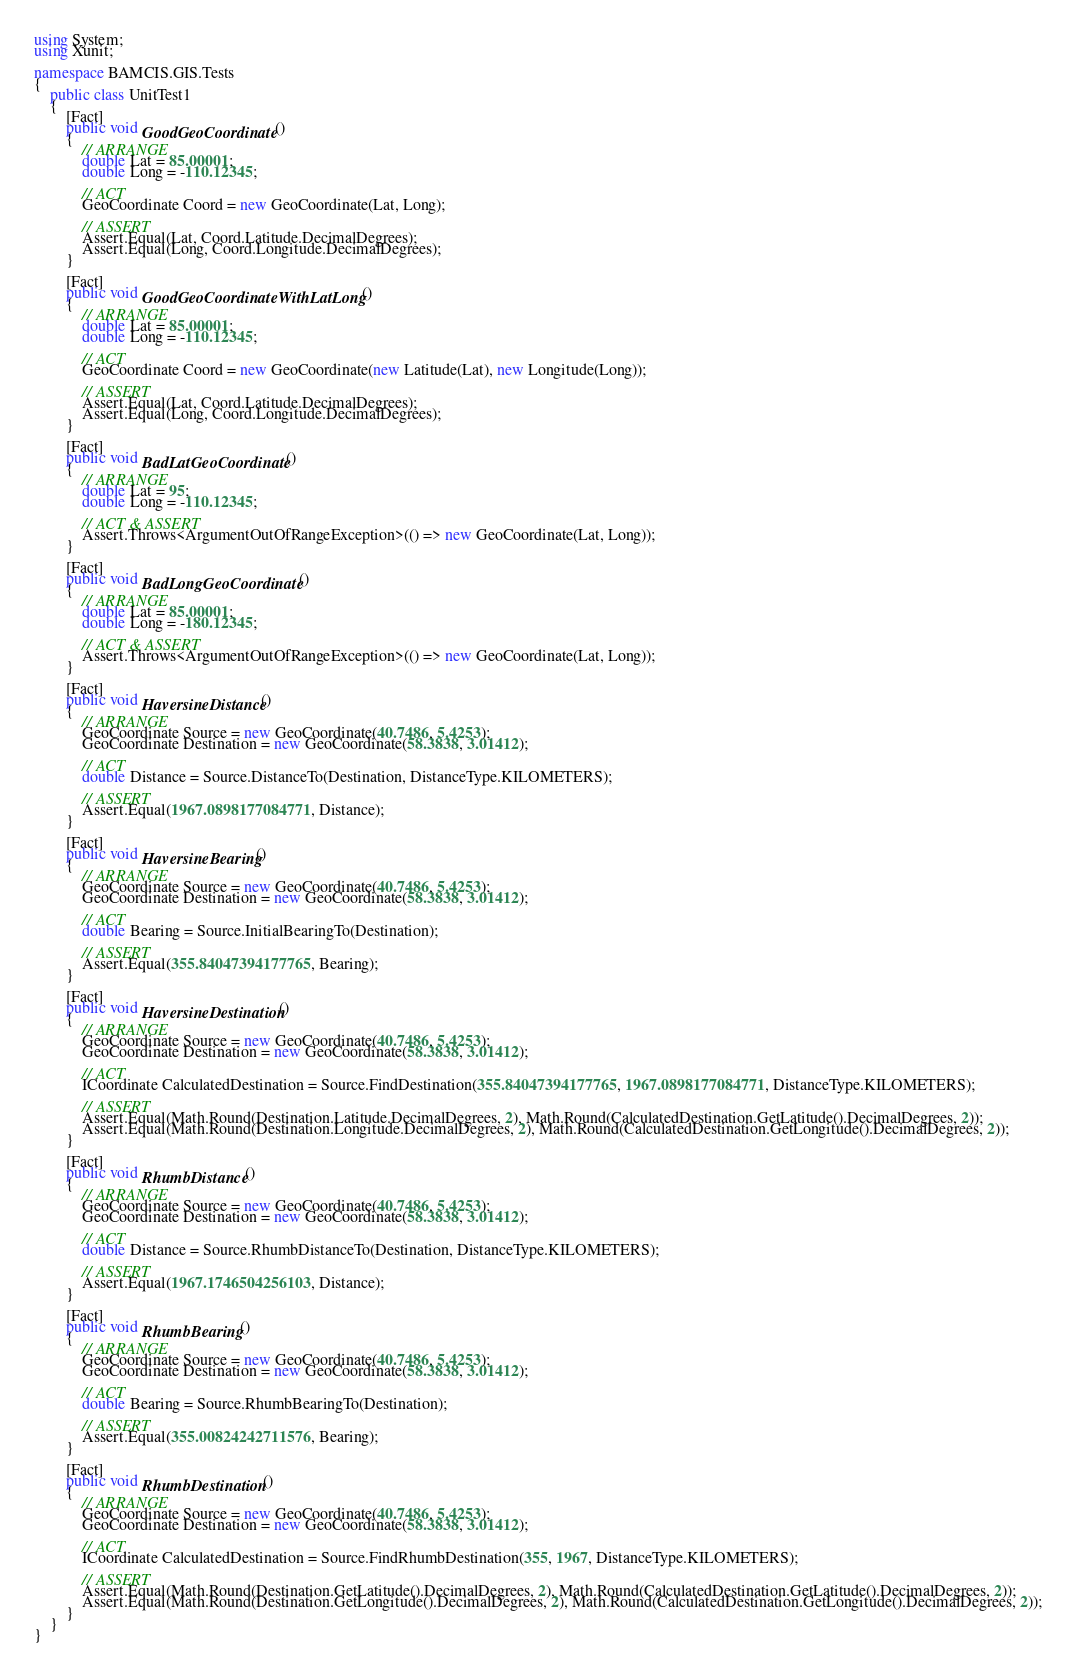<code> <loc_0><loc_0><loc_500><loc_500><_C#_>using System;
using Xunit;

namespace BAMCIS.GIS.Tests
{
    public class UnitTest1
    {
        [Fact]
        public void GoodGeoCoordinate()
        {
            // ARRANGE
            double Lat = 85.00001;
            double Long = -110.12345;

            // ACT
            GeoCoordinate Coord = new GeoCoordinate(Lat, Long);

            // ASSERT
            Assert.Equal(Lat, Coord.Latitude.DecimalDegrees);
            Assert.Equal(Long, Coord.Longitude.DecimalDegrees);
        }

        [Fact]
        public void GoodGeoCoordinateWithLatLong()
        {
            // ARRANGE
            double Lat = 85.00001;
            double Long = -110.12345;

            // ACT
            GeoCoordinate Coord = new GeoCoordinate(new Latitude(Lat), new Longitude(Long));

            // ASSERT
            Assert.Equal(Lat, Coord.Latitude.DecimalDegrees);
            Assert.Equal(Long, Coord.Longitude.DecimalDegrees);
        }

        [Fact]
        public void BadLatGeoCoordinate()
        {
            // ARRANGE
            double Lat = 95;
            double Long = -110.12345;

            // ACT & ASSERT
            Assert.Throws<ArgumentOutOfRangeException>(() => new GeoCoordinate(Lat, Long));
        }

        [Fact]
        public void BadLongGeoCoordinate()
        {
            // ARRANGE
            double Lat = 85.00001;
            double Long = -180.12345;

            // ACT & ASSERT
            Assert.Throws<ArgumentOutOfRangeException>(() => new GeoCoordinate(Lat, Long));
        }

        [Fact]
        public void HaversineDistance()
        {
            // ARRANGE
            GeoCoordinate Source = new GeoCoordinate(40.7486, 5.4253);
            GeoCoordinate Destination = new GeoCoordinate(58.3838, 3.01412);

            // ACT
            double Distance = Source.DistanceTo(Destination, DistanceType.KILOMETERS);

            // ASSERT
            Assert.Equal(1967.0898177084771, Distance);
        }

        [Fact]
        public void HaversineBearing()
        {
            // ARRANGE
            GeoCoordinate Source = new GeoCoordinate(40.7486, 5.4253);
            GeoCoordinate Destination = new GeoCoordinate(58.3838, 3.01412);

            // ACT
            double Bearing = Source.InitialBearingTo(Destination);

            // ASSERT
            Assert.Equal(355.84047394177765, Bearing);
        }

        [Fact]
        public void HaversineDestination()
        {
            // ARRANGE
            GeoCoordinate Source = new GeoCoordinate(40.7486, 5.4253);
            GeoCoordinate Destination = new GeoCoordinate(58.3838, 3.01412);

            // ACT
            ICoordinate CalculatedDestination = Source.FindDestination(355.84047394177765, 1967.0898177084771, DistanceType.KILOMETERS);

            // ASSERT
            Assert.Equal(Math.Round(Destination.Latitude.DecimalDegrees, 2), Math.Round(CalculatedDestination.GetLatitude().DecimalDegrees, 2));
            Assert.Equal(Math.Round(Destination.Longitude.DecimalDegrees, 2), Math.Round(CalculatedDestination.GetLongitude().DecimalDegrees, 2));
        }

        [Fact]
        public void RhumbDistance()
        {
            // ARRANGE
            GeoCoordinate Source = new GeoCoordinate(40.7486, 5.4253);
            GeoCoordinate Destination = new GeoCoordinate(58.3838, 3.01412);

            // ACT
            double Distance = Source.RhumbDistanceTo(Destination, DistanceType.KILOMETERS);

            // ASSERT
            Assert.Equal(1967.1746504256103, Distance);
        }

        [Fact]
        public void RhumbBearing()
        {
            // ARRANGE
            GeoCoordinate Source = new GeoCoordinate(40.7486, 5.4253);
            GeoCoordinate Destination = new GeoCoordinate(58.3838, 3.01412);

            // ACT
            double Bearing = Source.RhumbBearingTo(Destination);

            // ASSERT
            Assert.Equal(355.00824242711576, Bearing);
        }

        [Fact]
        public void RhumbDestination()
        {
            // ARRANGE
            GeoCoordinate Source = new GeoCoordinate(40.7486, 5.4253);
            GeoCoordinate Destination = new GeoCoordinate(58.3838, 3.01412);

            // ACT
            ICoordinate CalculatedDestination = Source.FindRhumbDestination(355, 1967, DistanceType.KILOMETERS);

            // ASSERT
            Assert.Equal(Math.Round(Destination.GetLatitude().DecimalDegrees, 2), Math.Round(CalculatedDestination.GetLatitude().DecimalDegrees, 2));
            Assert.Equal(Math.Round(Destination.GetLongitude().DecimalDegrees, 2), Math.Round(CalculatedDestination.GetLongitude().DecimalDegrees, 2));
        }
    }
}
</code> 